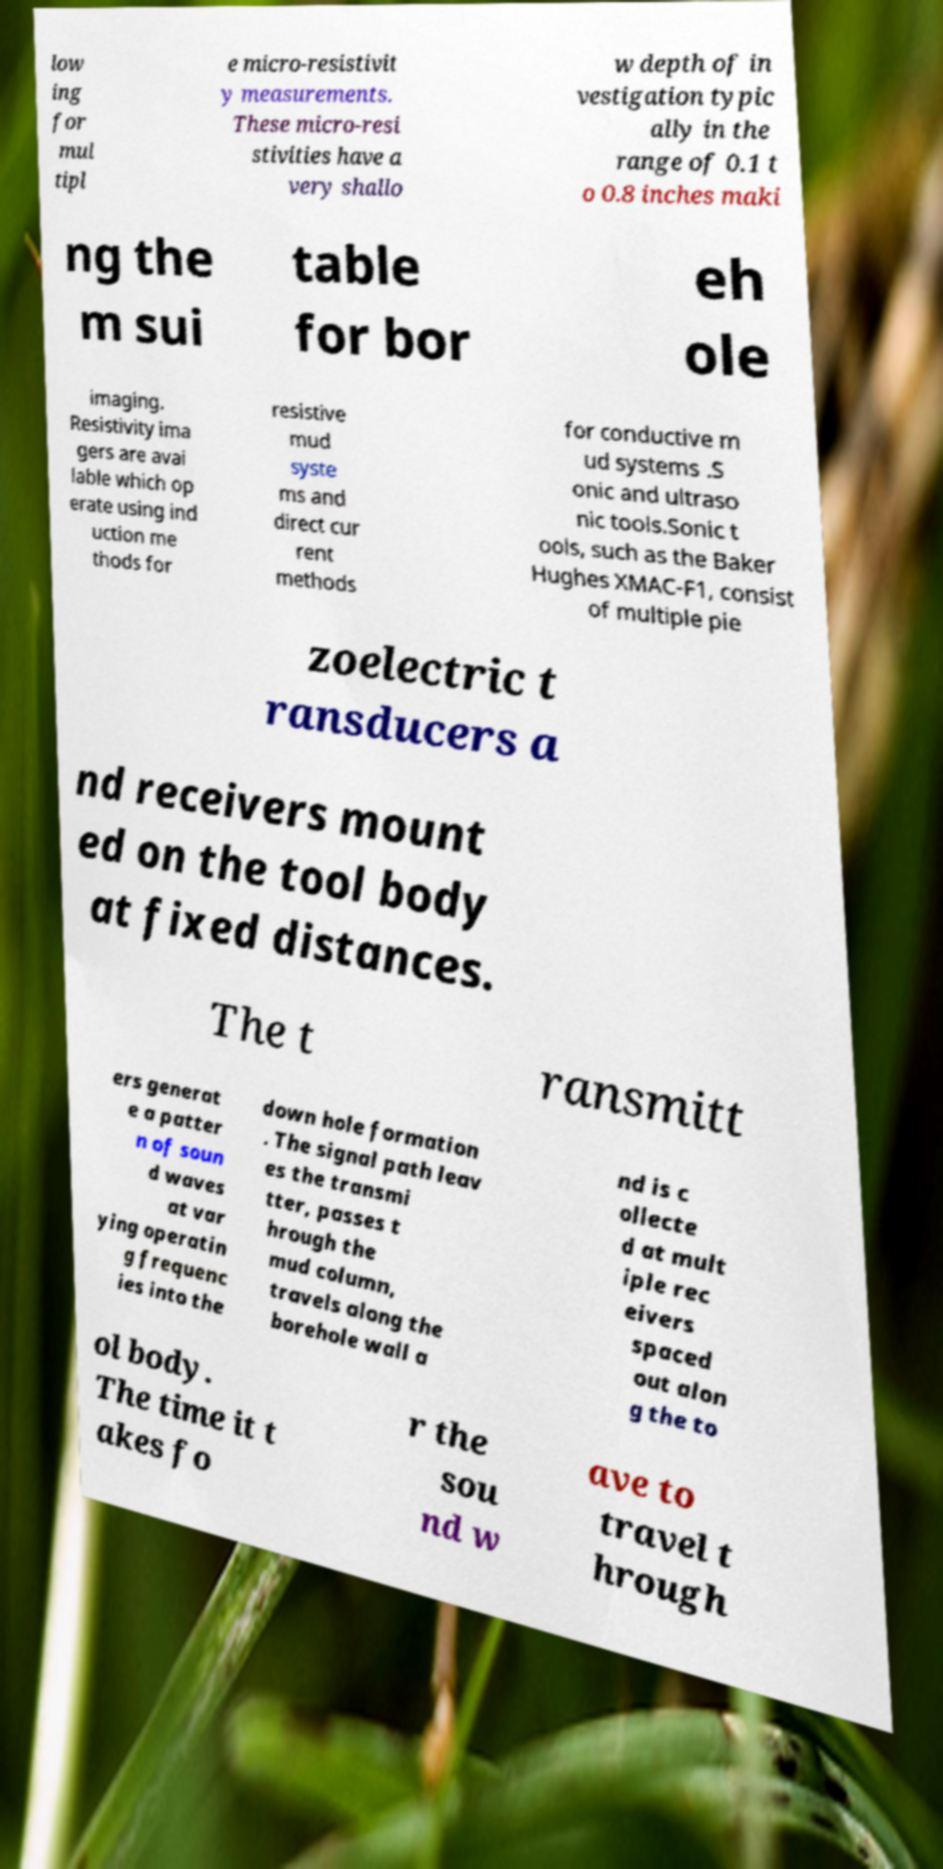Can you read and provide the text displayed in the image?This photo seems to have some interesting text. Can you extract and type it out for me? low ing for mul tipl e micro-resistivit y measurements. These micro-resi stivities have a very shallo w depth of in vestigation typic ally in the range of 0.1 t o 0.8 inches maki ng the m sui table for bor eh ole imaging. Resistivity ima gers are avai lable which op erate using ind uction me thods for resistive mud syste ms and direct cur rent methods for conductive m ud systems .S onic and ultraso nic tools.Sonic t ools, such as the Baker Hughes XMAC-F1, consist of multiple pie zoelectric t ransducers a nd receivers mount ed on the tool body at fixed distances. The t ransmitt ers generat e a patter n of soun d waves at var ying operatin g frequenc ies into the down hole formation . The signal path leav es the transmi tter, passes t hrough the mud column, travels along the borehole wall a nd is c ollecte d at mult iple rec eivers spaced out alon g the to ol body. The time it t akes fo r the sou nd w ave to travel t hrough 